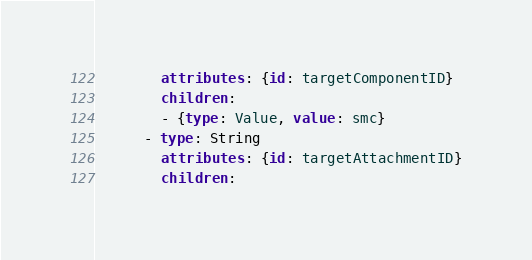<code> <loc_0><loc_0><loc_500><loc_500><_YAML_>        attributes: {id: targetComponentID}
        children:
        - {type: Value, value: smc}
      - type: String
        attributes: {id: targetAttachmentID}
        children:</code> 